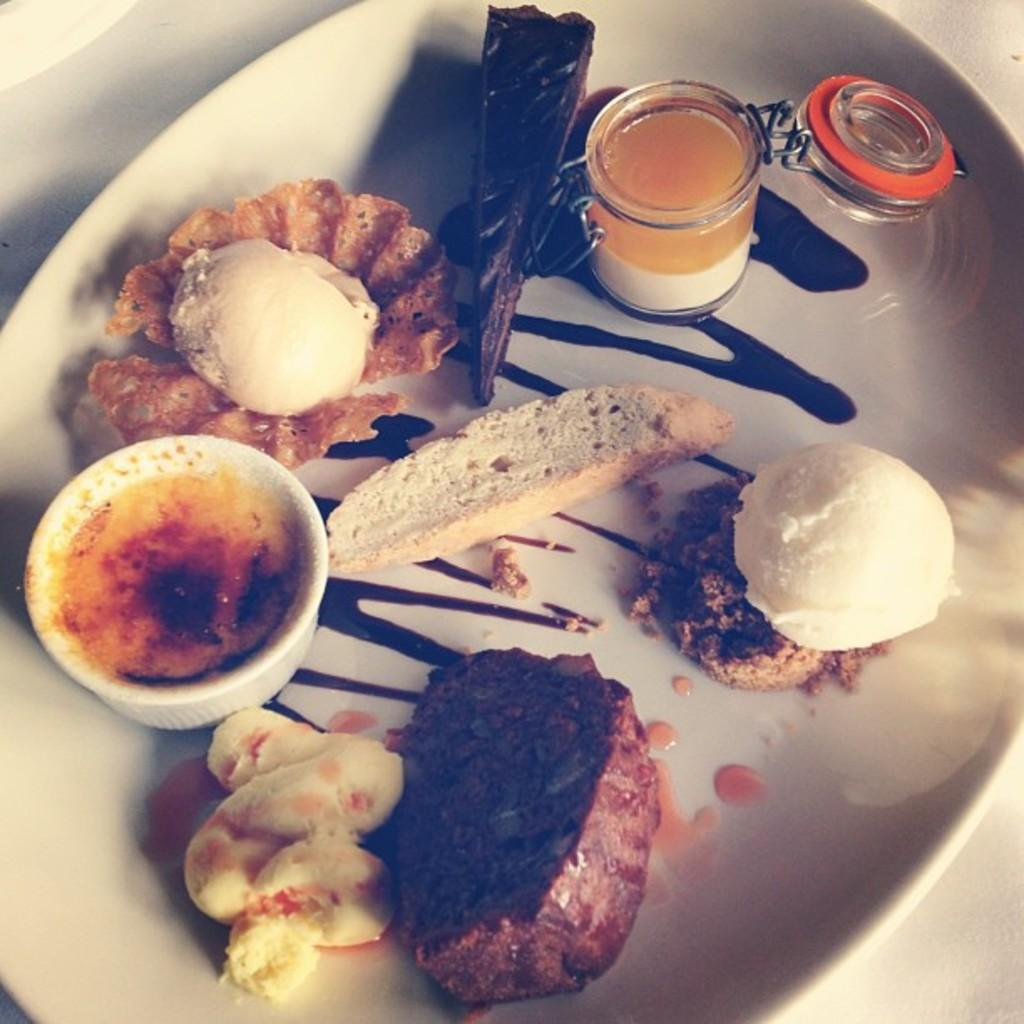What is in the bowl on the left side of the image? There is a bowl with curry in it on the left side of the image. What else can be seen in the image besides the bowl of curry? There are food items in a white color plate in the image. Can you see a volleyball being played in the image? No, there is no volleyball or any indication of a game being played in the image. 